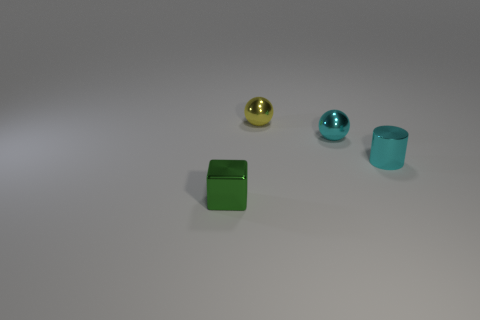Subtract 1 balls. How many balls are left? 1 Add 3 cyan shiny spheres. How many cyan shiny spheres are left? 4 Add 1 small yellow matte things. How many small yellow matte things exist? 1 Add 2 cyan objects. How many objects exist? 6 Subtract all yellow balls. How many balls are left? 1 Subtract 1 green blocks. How many objects are left? 3 Subtract all cubes. How many objects are left? 3 Subtract all red spheres. Subtract all brown blocks. How many spheres are left? 2 Subtract all yellow balls. How many yellow cubes are left? 0 Subtract all tiny green cubes. Subtract all cyan metal cylinders. How many objects are left? 2 